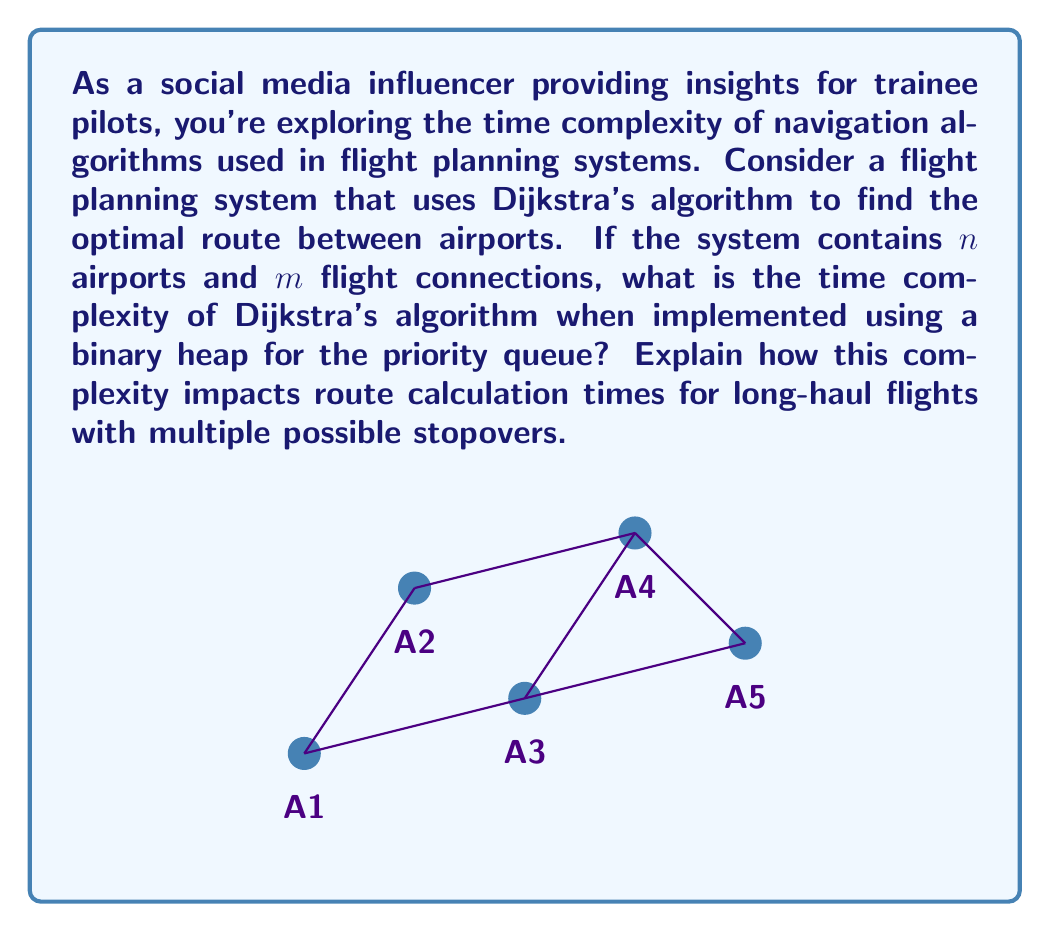Teach me how to tackle this problem. To analyze the time complexity of Dijkstra's algorithm using a binary heap, let's break it down step-by-step:

1) Initialization:
   - Creating the priority queue: $O(n)$
   - Setting initial distances: $O(n)$

2) Main loop:
   - The loop runs $n$ times (once for each airport)
   - Each iteration:
     a) Extract-min operation: $O(\log n)$
     b) For each adjacent airport (at most $m/n$ on average):
        - Update distance and decrease-key: $O(\log n)$

3) Total complexity:
   $O(n) + n \cdot O(\log n) + m \cdot O(\log n)$
   $= O(n + n\log n + m\log n)$
   $= O((n + m)\log n)$

Since $m \geq n-1$ in a connected graph, we can simplify this to $O(m \log n)$.

For long-haul flights with multiple stopovers:
- As the number of airports ($n$) increases, the complexity grows logarithmically
- As the number of connections ($m$) increases, the complexity grows linearly

This means that for dense networks with many flight connections, the algorithm's performance will degrade more quickly than for sparse networks. However, the use of a binary heap significantly improves performance compared to a naive implementation (which would be $O(n^2)$).

In practice, for a global flight network:
- $n$ might be around 10,000 (number of commercial airports)
- $m$ might be around 100,000 (number of flight routes)

So, the time complexity would be approximately $O(100,000 \log 10,000) \approx O(1,300,000)$ operations, which is manageable for modern computers and allows for real-time route calculations in most cases.
Answer: $O(m \log n)$ 